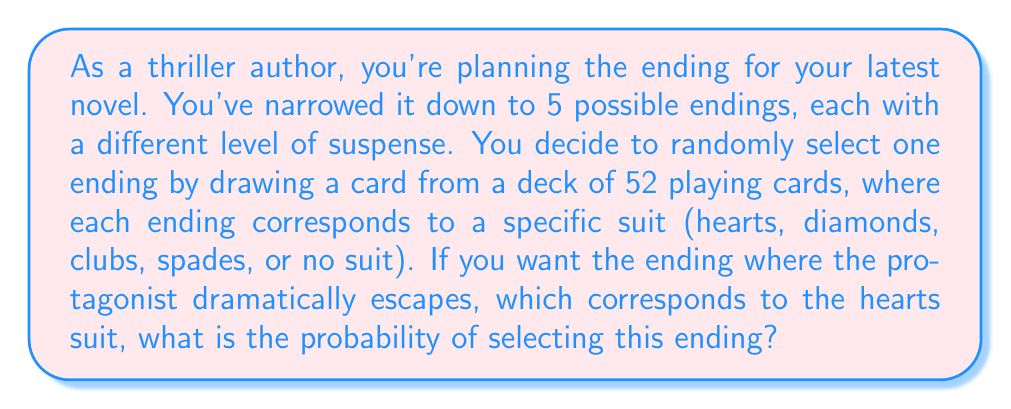Teach me how to tackle this problem. Let's approach this step-by-step:

1) First, we need to identify how many cards in a standard 52-card deck correspond to each ending:
   - Hearts (protagonist escapes): 13 cards
   - Diamonds: 13 cards
   - Clubs: 13 cards
   - Spades: 13 cards
   - No suit (Jokers, if included): 0 cards (typically not included in standard decks)

2) The probability of an event is calculated by:

   $$ P(\text{event}) = \frac{\text{number of favorable outcomes}}{\text{total number of possible outcomes}} $$

3) In this case:
   - Favorable outcomes: 13 (all heart cards)
   - Total possible outcomes: 52 (all cards in the deck)

4) Therefore, the probability is:

   $$ P(\text{selecting hearts}) = \frac{13}{52} $$

5) This fraction can be simplified:

   $$ \frac{13}{52} = \frac{1}{4} = 0.25 $$

Thus, there's a 1/4 or 25% chance of selecting the ending where the protagonist dramatically escapes.
Answer: $\frac{1}{4}$ or 0.25 or 25% 